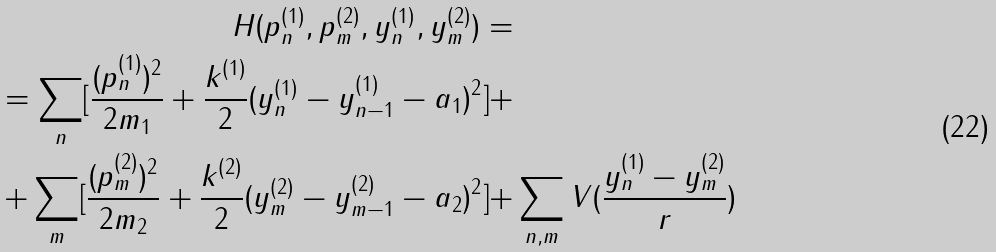Convert formula to latex. <formula><loc_0><loc_0><loc_500><loc_500>H ( p ^ { ( 1 ) } _ { n } , p ^ { ( 2 ) } _ { m } , y ^ { ( 1 ) } _ { n } , y ^ { ( 2 ) } _ { m } ) = & \\ = \sum _ { n } [ \frac { ( p ^ { ( 1 ) } _ { n } ) ^ { 2 } } { 2 m _ { 1 } } + \frac { k ^ { ( 1 ) } } { 2 } ( y ^ { ( 1 ) } _ { n } - y ^ { ( 1 ) } _ { n - 1 } - a _ { 1 } ) ^ { 2 } ] + & \\ + \sum _ { m } [ \frac { ( p ^ { ( 2 ) } _ { m } ) ^ { 2 } } { 2 m _ { 2 } } + \frac { k ^ { ( 2 ) } } { 2 } ( y ^ { ( 2 ) } _ { m } - y ^ { ( 2 ) } _ { m - 1 } - a _ { 2 } ) ^ { 2 } ] + & \sum _ { n , m } V ( \frac { y ^ { ( 1 ) } _ { n } - y ^ { ( 2 ) } _ { m } } { r } )</formula> 